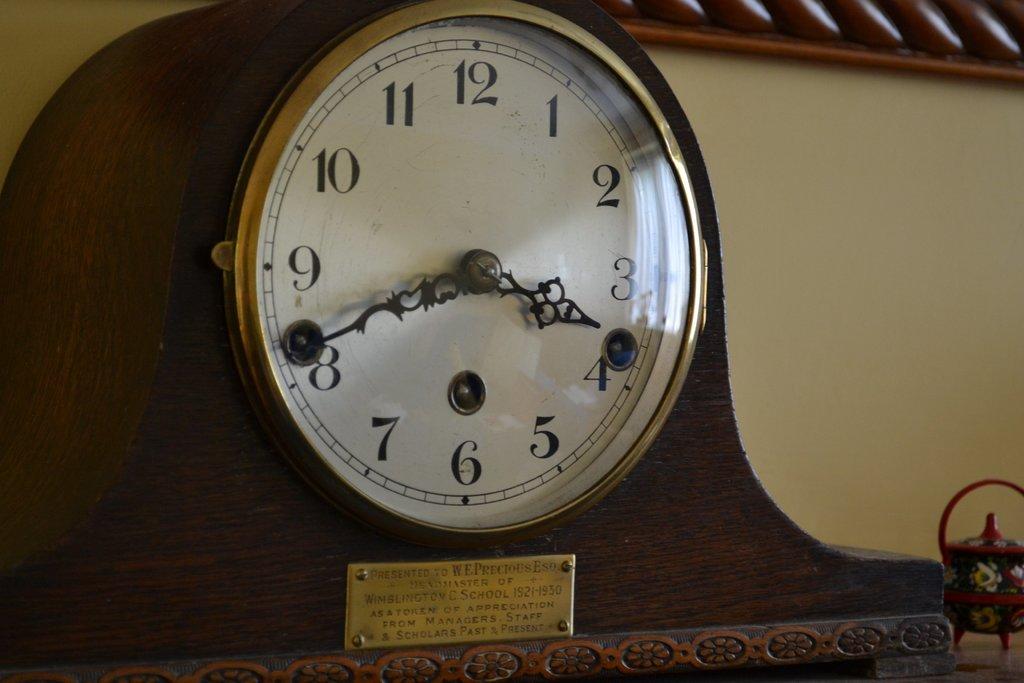What time can be seen on the clock?
Make the answer very short. 3:42. 